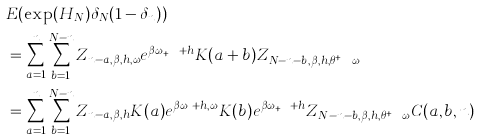<formula> <loc_0><loc_0><loc_500><loc_500>& E ( \exp ( H _ { N } ) \delta _ { N } ( 1 - \delta _ { n } ) ) \\ & = \sum _ { a = 1 } ^ { n } \sum _ { b = 1 } ^ { N - n } Z _ { n - a , \beta , h , \omega } e ^ { \beta \omega _ { n + b } + h } K ( a + b ) Z _ { N - n - b , \beta , h , \theta ^ { n + h } \omega } \\ & = \sum _ { a = 1 } ^ { n } \sum _ { b = 1 } ^ { N - n } Z _ { n - a , \beta , h } K ( a ) e ^ { \beta \omega _ { n } + h , \omega } K ( b ) e ^ { \beta \omega _ { n + b } + h } Z _ { N - n - b , \beta , h , \theta ^ { n + h } \omega } C ( a , b , n )</formula> 